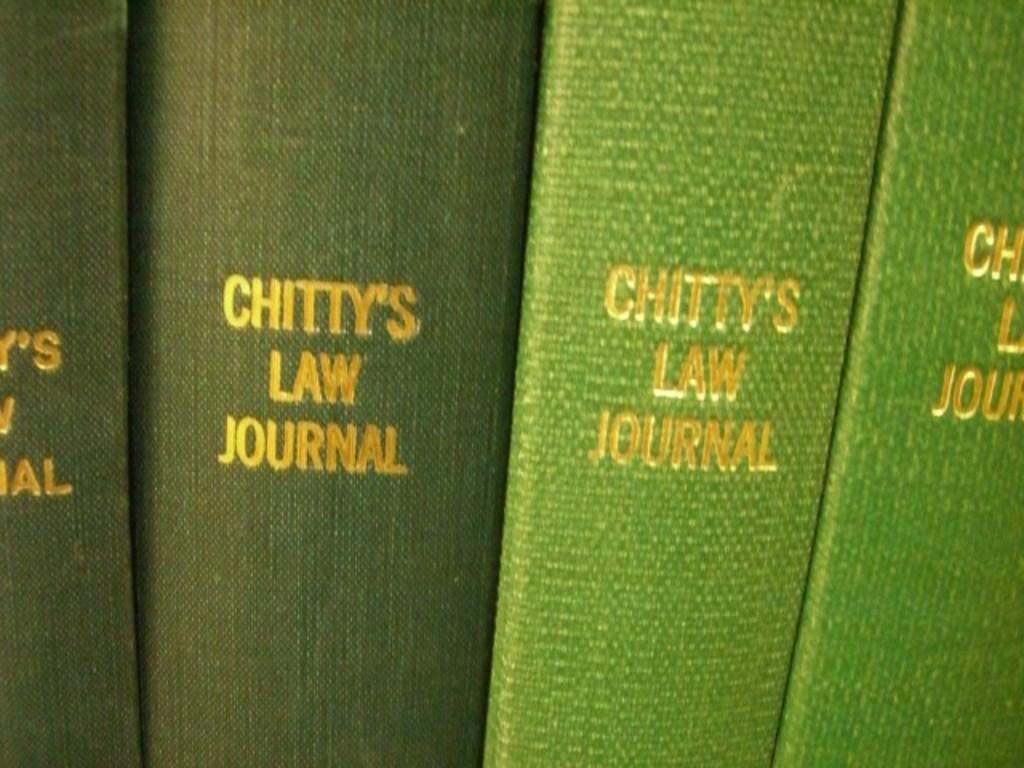Provide a one-sentence caption for the provided image. Various old bound books that are green in color and say Chitty's law Journal. 